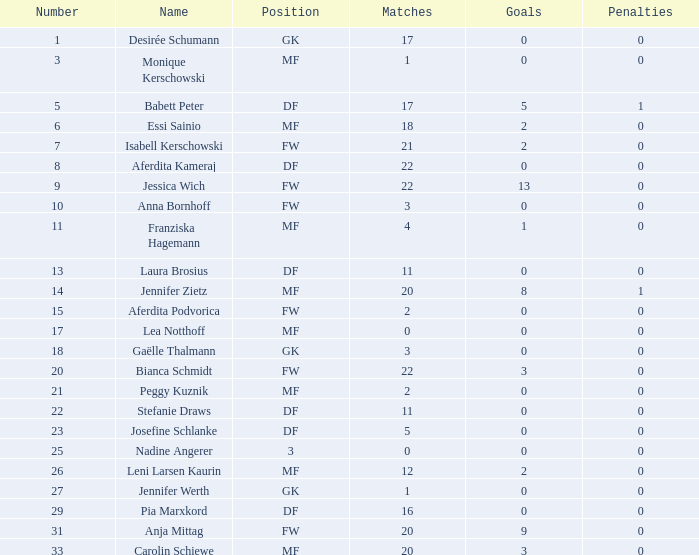Can you parse all the data within this table? {'header': ['Number', 'Name', 'Position', 'Matches', 'Goals', 'Penalties'], 'rows': [['1', 'Desirée Schumann', 'GK', '17', '0', '0'], ['3', 'Monique Kerschowski', 'MF', '1', '0', '0'], ['5', 'Babett Peter', 'DF', '17', '5', '1'], ['6', 'Essi Sainio', 'MF', '18', '2', '0'], ['7', 'Isabell Kerschowski', 'FW', '21', '2', '0'], ['8', 'Aferdita Kameraj', 'DF', '22', '0', '0'], ['9', 'Jessica Wich', 'FW', '22', '13', '0'], ['10', 'Anna Bornhoff', 'FW', '3', '0', '0'], ['11', 'Franziska Hagemann', 'MF', '4', '1', '0'], ['13', 'Laura Brosius', 'DF', '11', '0', '0'], ['14', 'Jennifer Zietz', 'MF', '20', '8', '1'], ['15', 'Aferdita Podvorica', 'FW', '2', '0', '0'], ['17', 'Lea Notthoff', 'MF', '0', '0', '0'], ['18', 'Gaëlle Thalmann', 'GK', '3', '0', '0'], ['20', 'Bianca Schmidt', 'FW', '22', '3', '0'], ['21', 'Peggy Kuznik', 'MF', '2', '0', '0'], ['22', 'Stefanie Draws', 'DF', '11', '0', '0'], ['23', 'Josefine Schlanke', 'DF', '5', '0', '0'], ['25', 'Nadine Angerer', '3', '0', '0', '0'], ['26', 'Leni Larsen Kaurin', 'MF', '12', '2', '0'], ['27', 'Jennifer Werth', 'GK', '1', '0', '0'], ['29', 'Pia Marxkord', 'DF', '16', '0', '0'], ['31', 'Anja Mittag', 'FW', '20', '9', '0'], ['33', 'Carolin Schiewe', 'MF', '20', '3', '0']]} What is the mean goals for essi sainio? 2.0. 